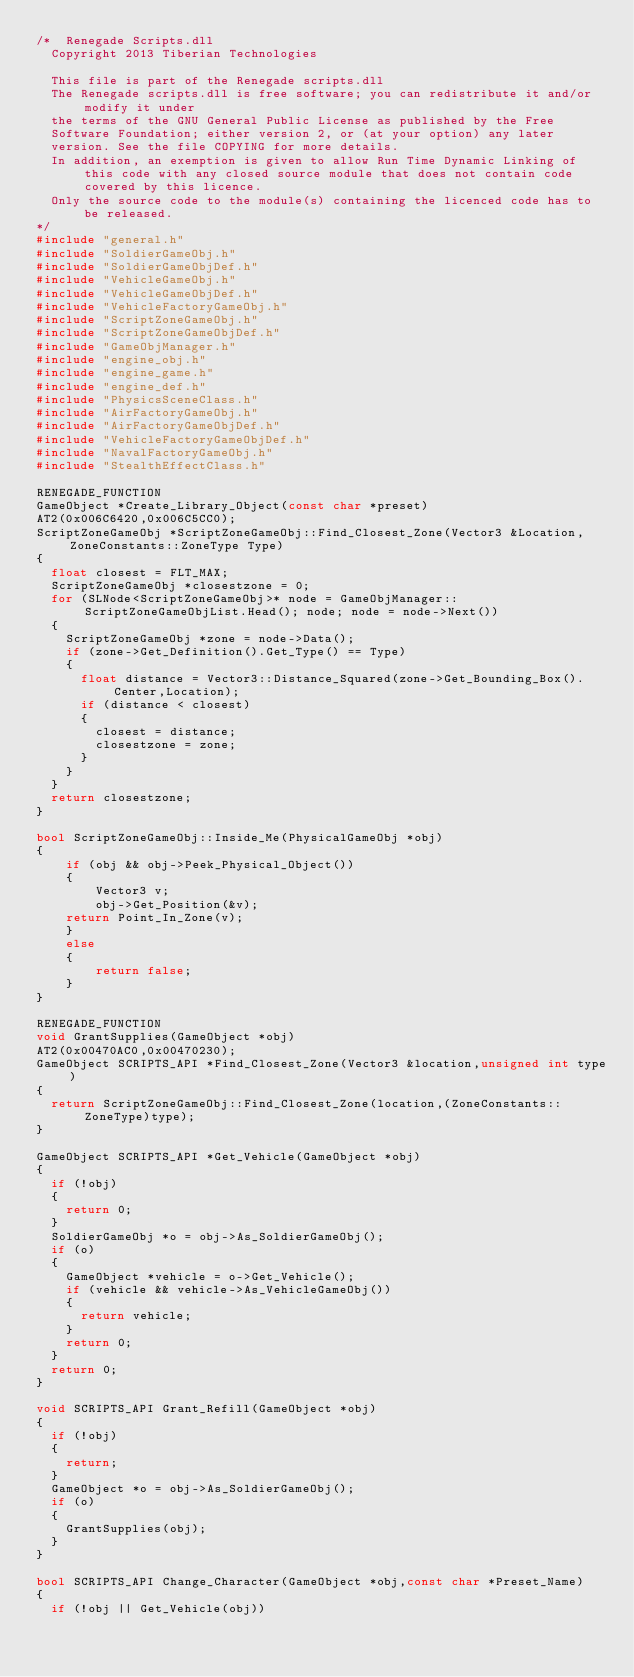Convert code to text. <code><loc_0><loc_0><loc_500><loc_500><_C++_>/*	Renegade Scripts.dll
	Copyright 2013 Tiberian Technologies

	This file is part of the Renegade scripts.dll
	The Renegade scripts.dll is free software; you can redistribute it and/or modify it under
	the terms of the GNU General Public License as published by the Free
	Software Foundation; either version 2, or (at your option) any later
	version. See the file COPYING for more details.
	In addition, an exemption is given to allow Run Time Dynamic Linking of this code with any closed source module that does not contain code covered by this licence.
	Only the source code to the module(s) containing the licenced code has to be released.
*/
#include "general.h"
#include "SoldierGameObj.h"
#include "SoldierGameObjDef.h"
#include "VehicleGameObj.h"
#include "VehicleGameObjDef.h"
#include "VehicleFactoryGameObj.h"
#include "ScriptZoneGameObj.h"
#include "ScriptZoneGameObjDef.h"
#include "GameObjManager.h"
#include "engine_obj.h"
#include "engine_game.h"
#include "engine_def.h"
#include "PhysicsSceneClass.h"
#include "AirFactoryGameObj.h"
#include "AirFactoryGameObjDef.h"
#include "VehicleFactoryGameObjDef.h"
#include "NavalFactoryGameObj.h"
#include "StealthEffectClass.h"

RENEGADE_FUNCTION
GameObject *Create_Library_Object(const char *preset)
AT2(0x006C6420,0x006C5CC0);
ScriptZoneGameObj *ScriptZoneGameObj::Find_Closest_Zone(Vector3 &Location,ZoneConstants::ZoneType Type)
{
	float closest = FLT_MAX;
	ScriptZoneGameObj *closestzone = 0;
	for (SLNode<ScriptZoneGameObj>* node = GameObjManager::ScriptZoneGameObjList.Head(); node; node = node->Next())
	{
		ScriptZoneGameObj *zone = node->Data();
		if (zone->Get_Definition().Get_Type() == Type)
		{
			float distance = Vector3::Distance_Squared(zone->Get_Bounding_Box().Center,Location);
			if (distance < closest)
			{
				closest = distance;
				closestzone = zone;
			}
		}
	}
	return closestzone;
}

bool ScriptZoneGameObj::Inside_Me(PhysicalGameObj *obj)
{
    if (obj && obj->Peek_Physical_Object())
    {
        Vector3 v;
        obj->Get_Position(&v);
		return Point_In_Zone(v);
    }
    else
    {
        return false;
    }
}

RENEGADE_FUNCTION
void GrantSupplies(GameObject *obj)
AT2(0x00470AC0,0x00470230);
GameObject SCRIPTS_API *Find_Closest_Zone(Vector3 &location,unsigned int type)
{
	return ScriptZoneGameObj::Find_Closest_Zone(location,(ZoneConstants::ZoneType)type);
}

GameObject SCRIPTS_API *Get_Vehicle(GameObject *obj)
{
	if (!obj)
	{
		return 0;
	}
	SoldierGameObj *o = obj->As_SoldierGameObj();
	if (o)
	{
		GameObject *vehicle = o->Get_Vehicle();
		if (vehicle && vehicle->As_VehicleGameObj())
		{
			return vehicle;
		}
		return 0;
	}
	return 0;
}

void SCRIPTS_API Grant_Refill(GameObject *obj)
{
	if (!obj)
	{
		return;
	}
	GameObject *o = obj->As_SoldierGameObj();
	if (o)
	{
		GrantSupplies(obj);
	}
}

bool SCRIPTS_API Change_Character(GameObject *obj,const char *Preset_Name)
{
	if (!obj || Get_Vehicle(obj))</code> 